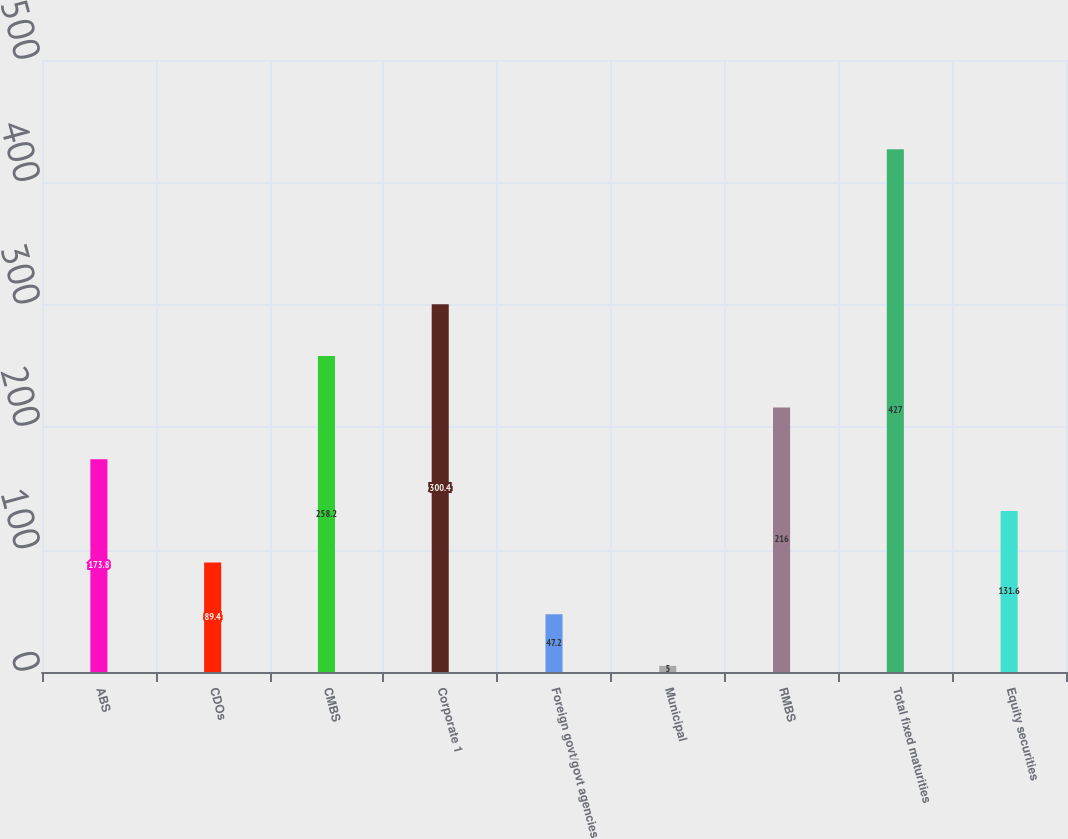Convert chart to OTSL. <chart><loc_0><loc_0><loc_500><loc_500><bar_chart><fcel>ABS<fcel>CDOs<fcel>CMBS<fcel>Corporate 1<fcel>Foreign govt/govt agencies<fcel>Municipal<fcel>RMBS<fcel>Total fixed maturities<fcel>Equity securities<nl><fcel>173.8<fcel>89.4<fcel>258.2<fcel>300.4<fcel>47.2<fcel>5<fcel>216<fcel>427<fcel>131.6<nl></chart> 